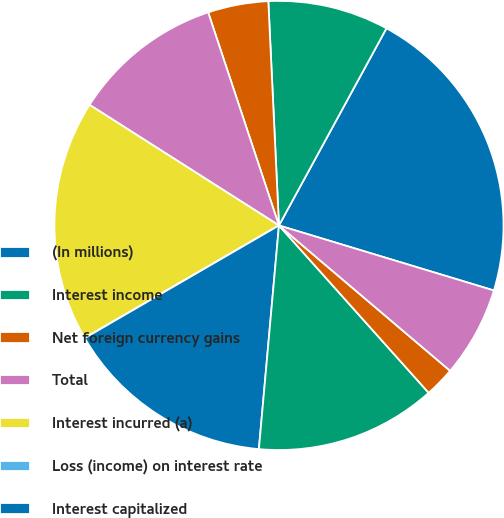Convert chart. <chart><loc_0><loc_0><loc_500><loc_500><pie_chart><fcel>(In millions)<fcel>Interest income<fcel>Net foreign currency gains<fcel>Total<fcel>Interest incurred (a)<fcel>Loss (income) on interest rate<fcel>Interest capitalized<fcel>Net interest expense<fcel>Other<fcel>Net interest and other<nl><fcel>21.73%<fcel>8.7%<fcel>4.35%<fcel>10.87%<fcel>17.38%<fcel>0.01%<fcel>15.21%<fcel>13.04%<fcel>2.18%<fcel>6.53%<nl></chart> 